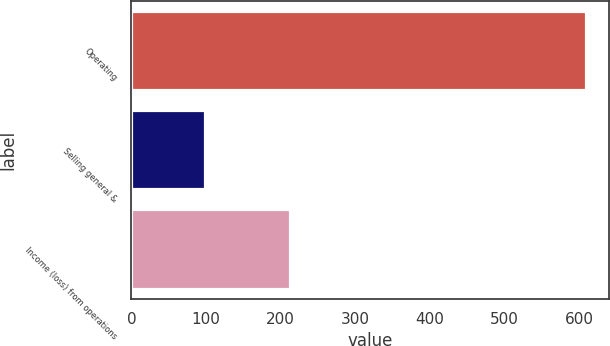Convert chart to OTSL. <chart><loc_0><loc_0><loc_500><loc_500><bar_chart><fcel>Operating<fcel>Selling general &<fcel>Income (loss) from operations<nl><fcel>610<fcel>98<fcel>212<nl></chart> 